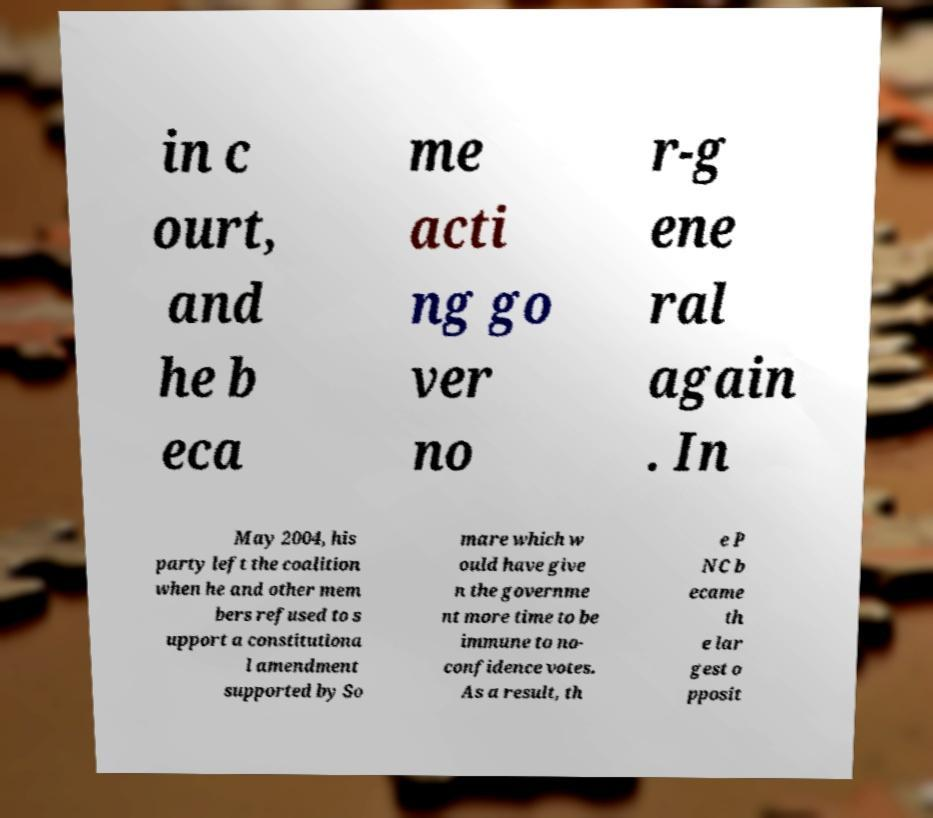Please read and relay the text visible in this image. What does it say? in c ourt, and he b eca me acti ng go ver no r-g ene ral again . In May 2004, his party left the coalition when he and other mem bers refused to s upport a constitutiona l amendment supported by So mare which w ould have give n the governme nt more time to be immune to no- confidence votes. As a result, th e P NC b ecame th e lar gest o pposit 